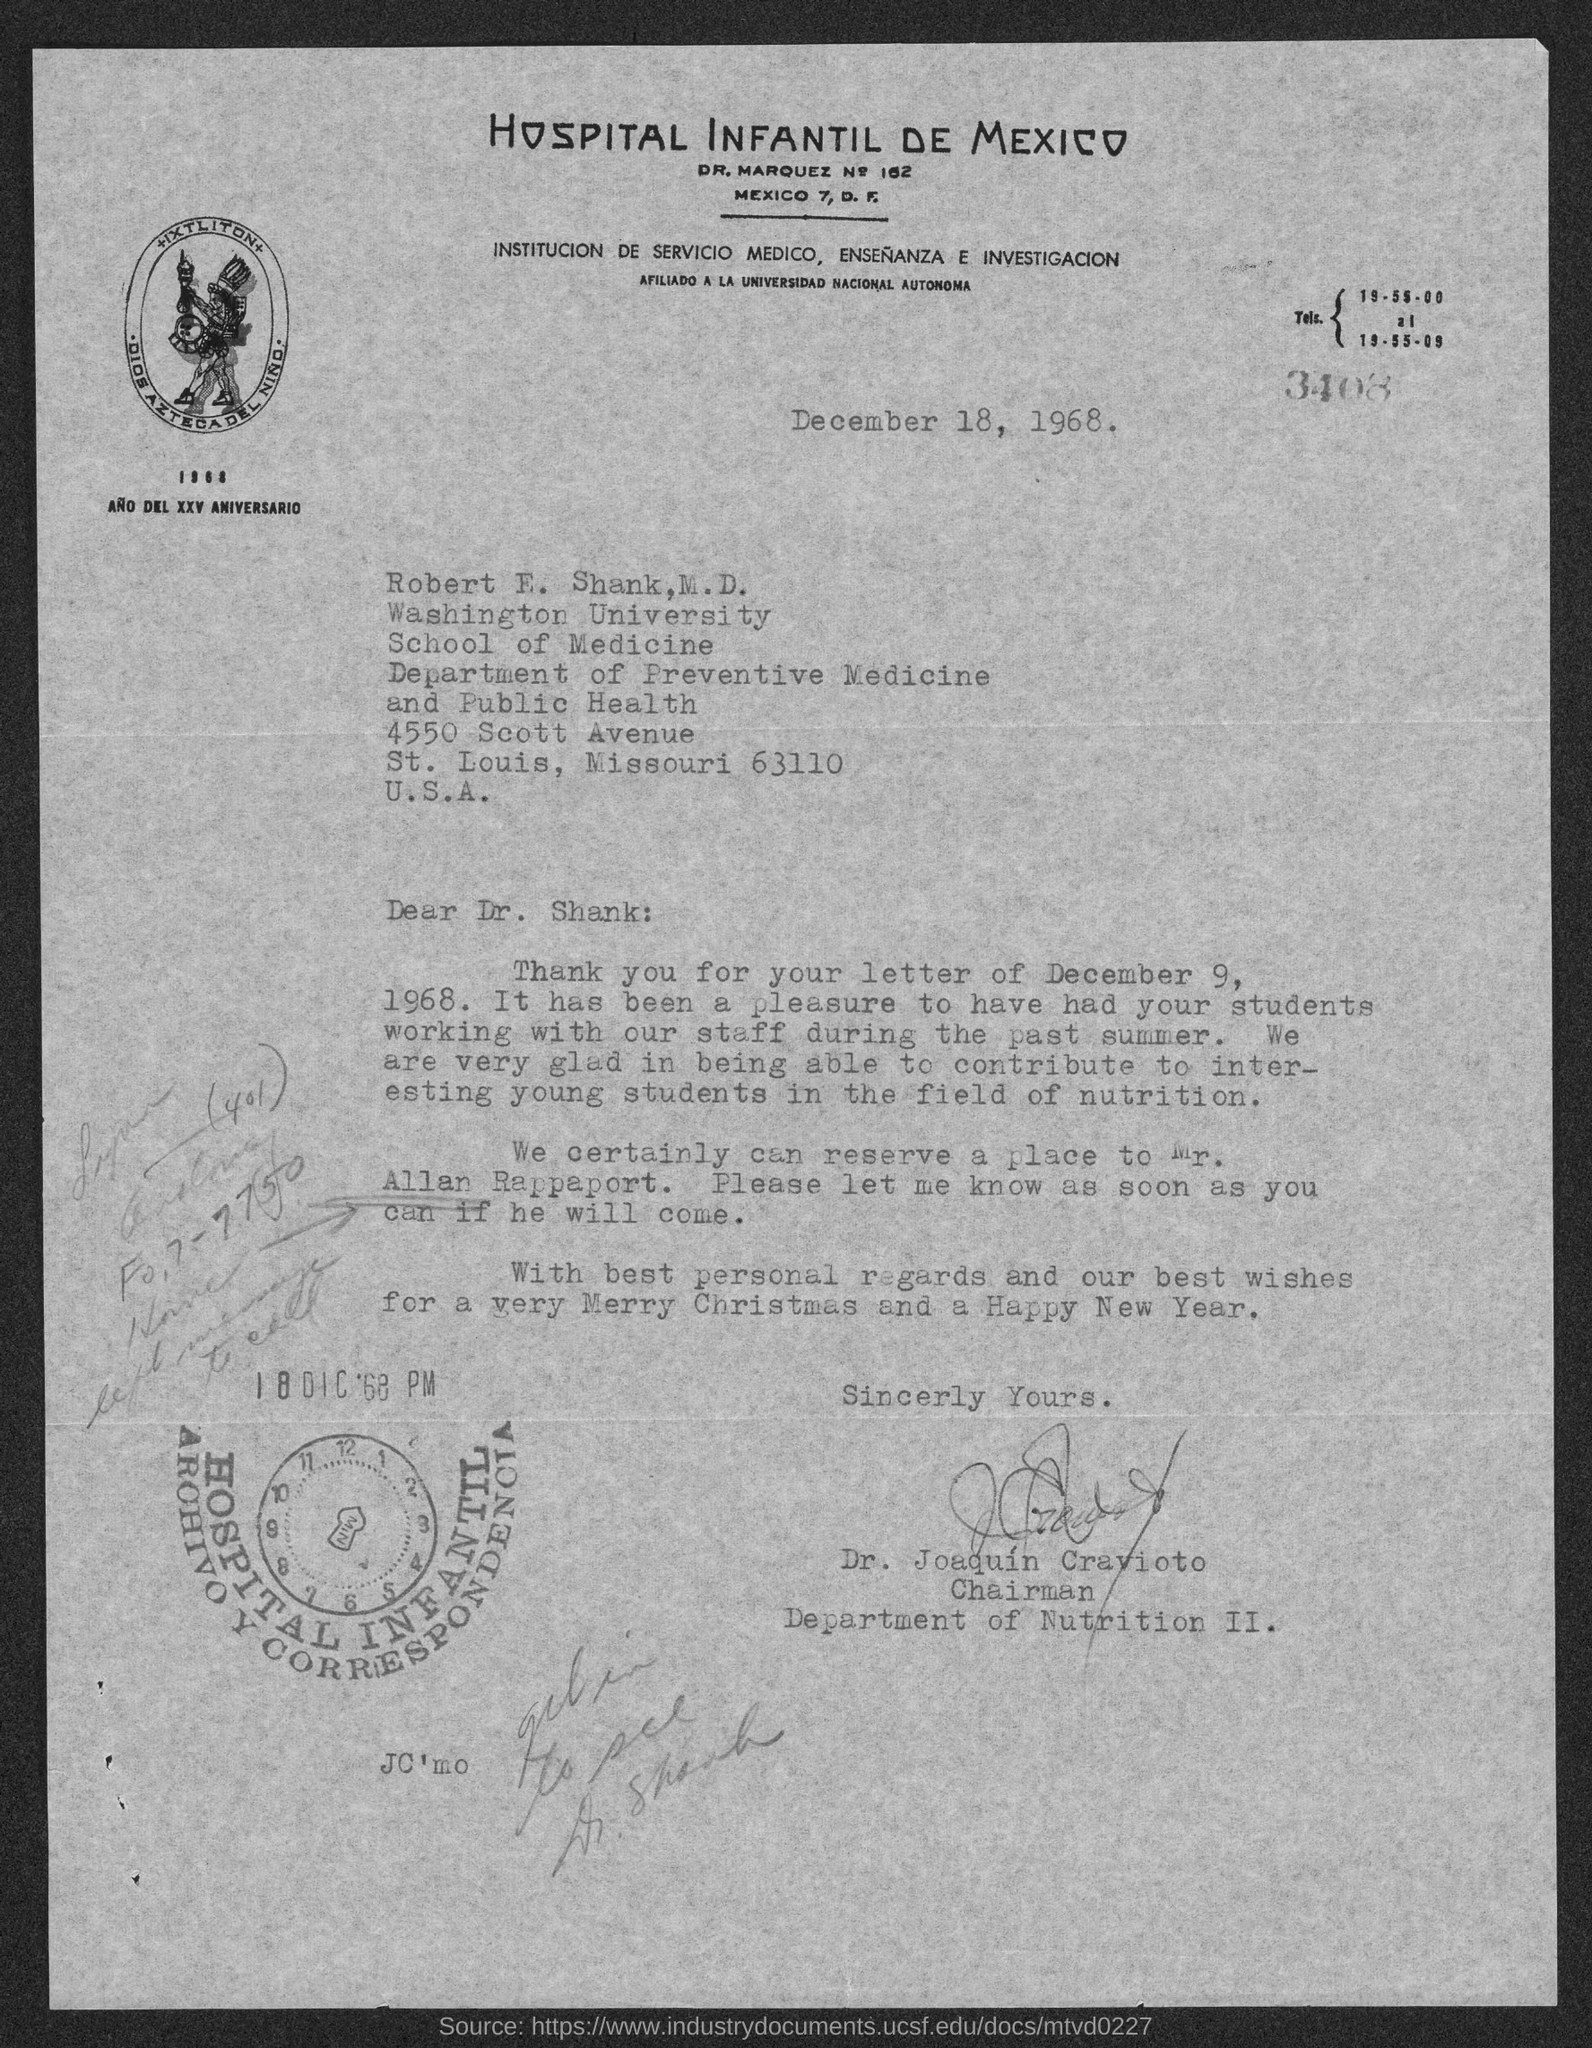List a handful of essential elements in this visual. The document at the top bears the inscription 'Hospital Infantil De Mexico.' The date mentioned at the top of the document is December 18, 1968. 